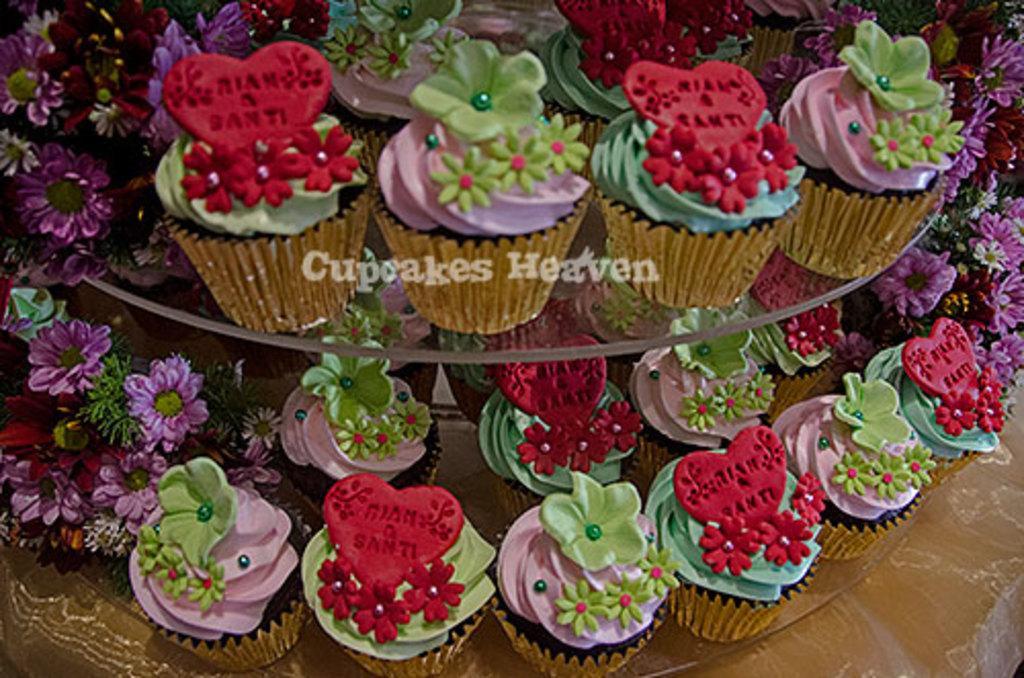Please provide a concise description of this image. In this image we can see cupcakes placed in the stand and we can see flowers. 